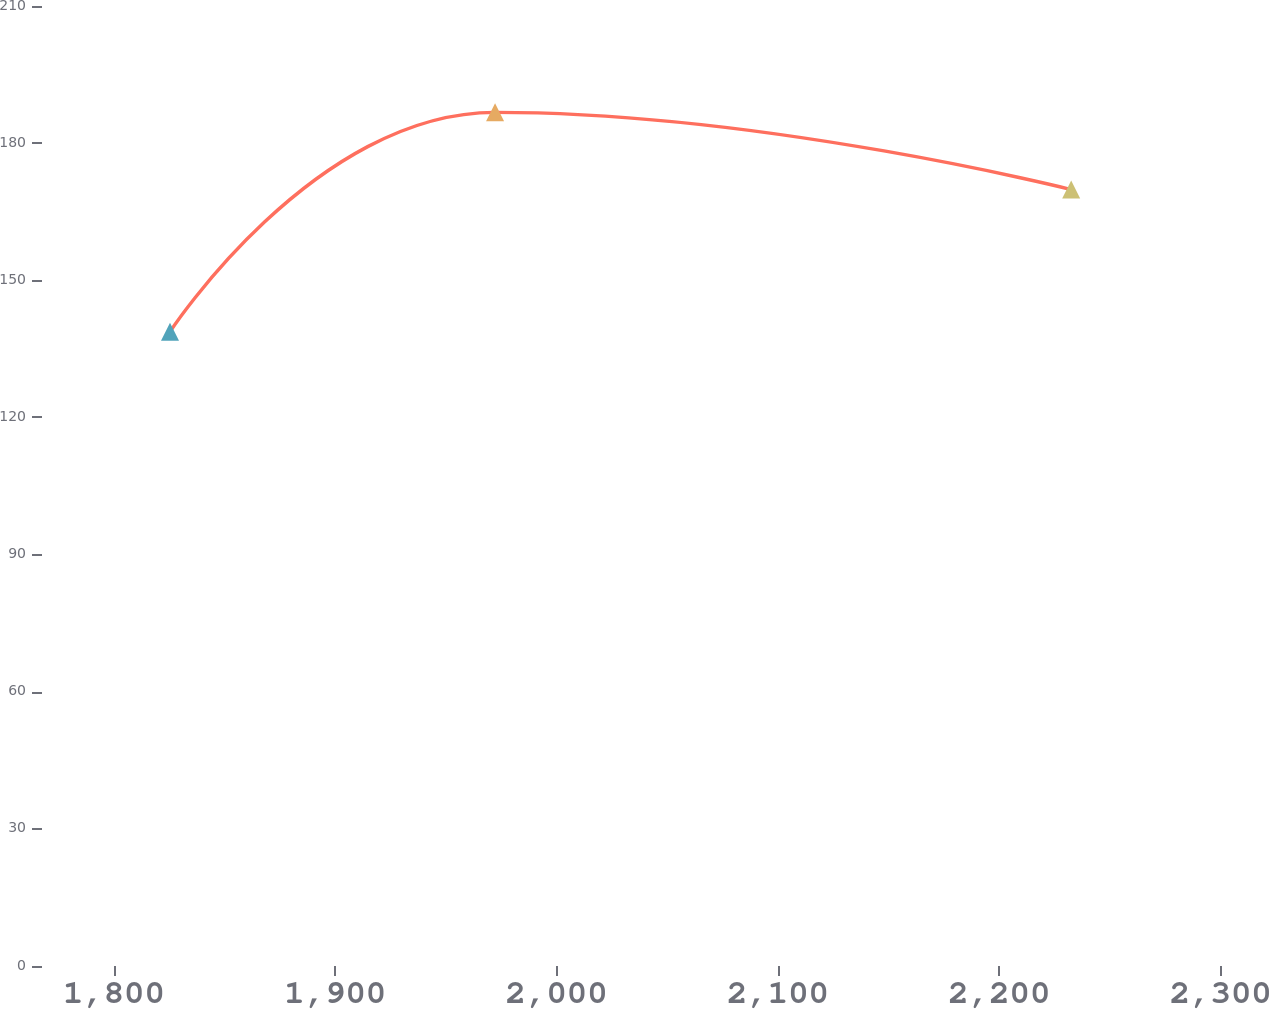<chart> <loc_0><loc_0><loc_500><loc_500><line_chart><ecel><fcel>(In thousands)<nl><fcel>1825.35<fcel>138.73<nl><fcel>1972.21<fcel>186.74<nl><fcel>2232.47<fcel>169.85<nl><fcel>2348.8<fcel>216.2<nl><fcel>2403.59<fcel>194.97<nl></chart> 